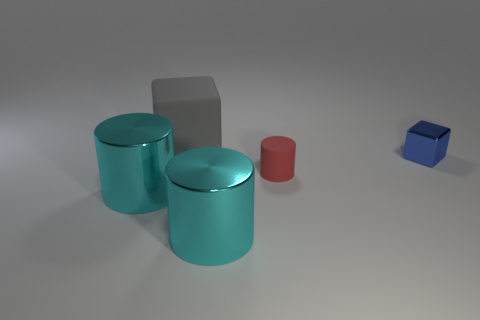There is a thing that is both to the left of the blue metallic block and behind the tiny red cylinder; what size is it?
Offer a very short reply. Large. Do the rubber thing behind the small cylinder and the small metal block have the same color?
Keep it short and to the point. No. Are there fewer big things that are to the right of the big gray cube than large red rubber cubes?
Offer a very short reply. No. What shape is the large object that is made of the same material as the tiny cylinder?
Give a very brief answer. Cube. Is the small red object made of the same material as the small blue thing?
Your answer should be compact. No. Is the number of cyan cylinders behind the big gray rubber cube less than the number of large metal things on the right side of the small block?
Your response must be concise. No. How many big metal cylinders are on the right side of the cube that is to the left of the small red rubber cylinder in front of the large gray matte cube?
Your response must be concise. 1. Does the large cube have the same color as the rubber cylinder?
Your answer should be very brief. No. Are there any tiny rubber blocks that have the same color as the tiny rubber object?
Keep it short and to the point. No. There is a rubber thing that is the same size as the blue metal object; what color is it?
Keep it short and to the point. Red. 